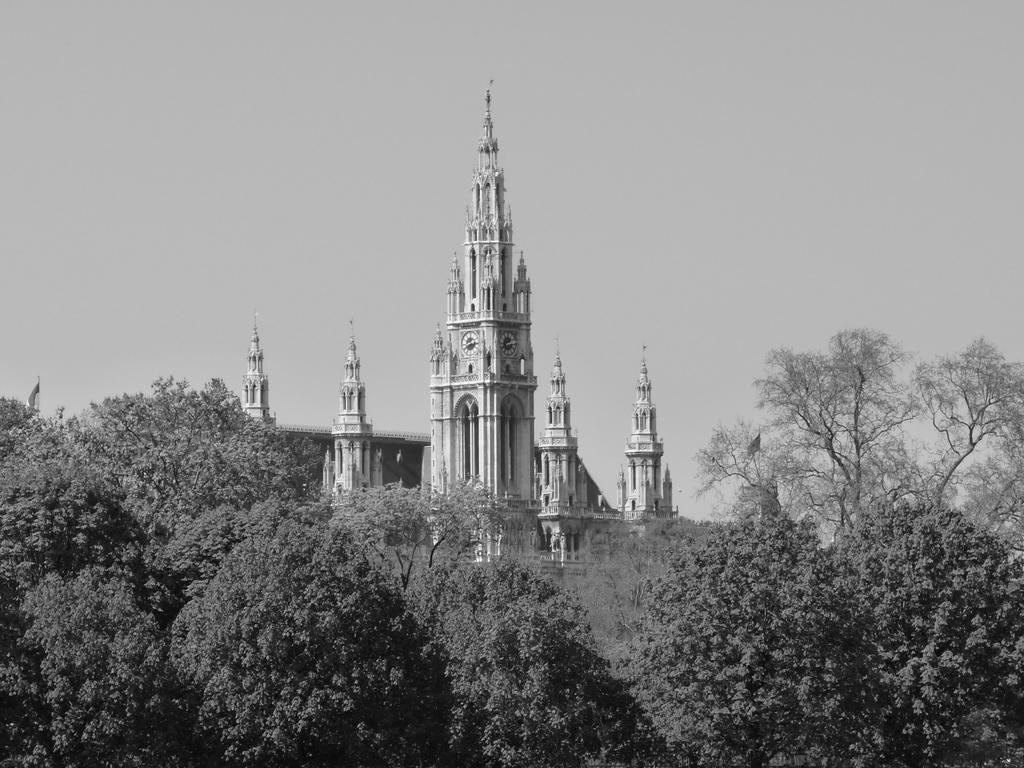What is the color scheme of the image? The image is black and white. What type of natural elements can be seen at the bottom of the image? There are trees at the bottom of the image. What type of structures are present in the image? There are buildings with pillars in the image. What architectural features can be seen in the image? There are walls and poles in the image. What time-related object is present in the image? There is a clock in the image. What is the price of the roof in the image? There is no roof present in the image, and therefore no price can be determined. 